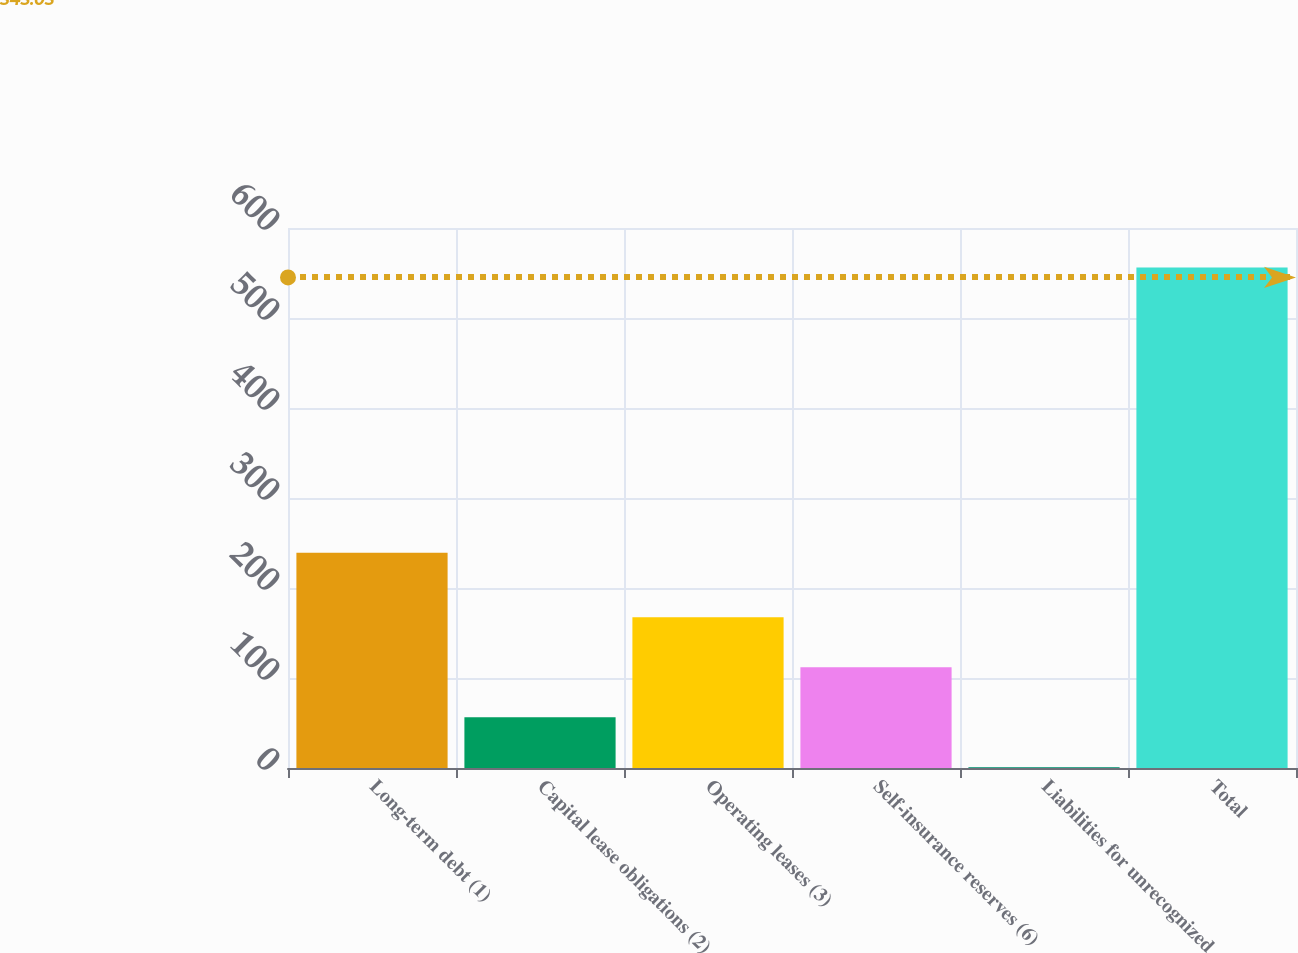<chart> <loc_0><loc_0><loc_500><loc_500><bar_chart><fcel>Long-term debt (1)<fcel>Capital lease obligations (2)<fcel>Operating leases (3)<fcel>Self-insurance reserves (6)<fcel>Liabilities for unrecognized<fcel>Total<nl><fcel>239.2<fcel>56.5<fcel>167.5<fcel>112<fcel>1<fcel>556<nl></chart> 